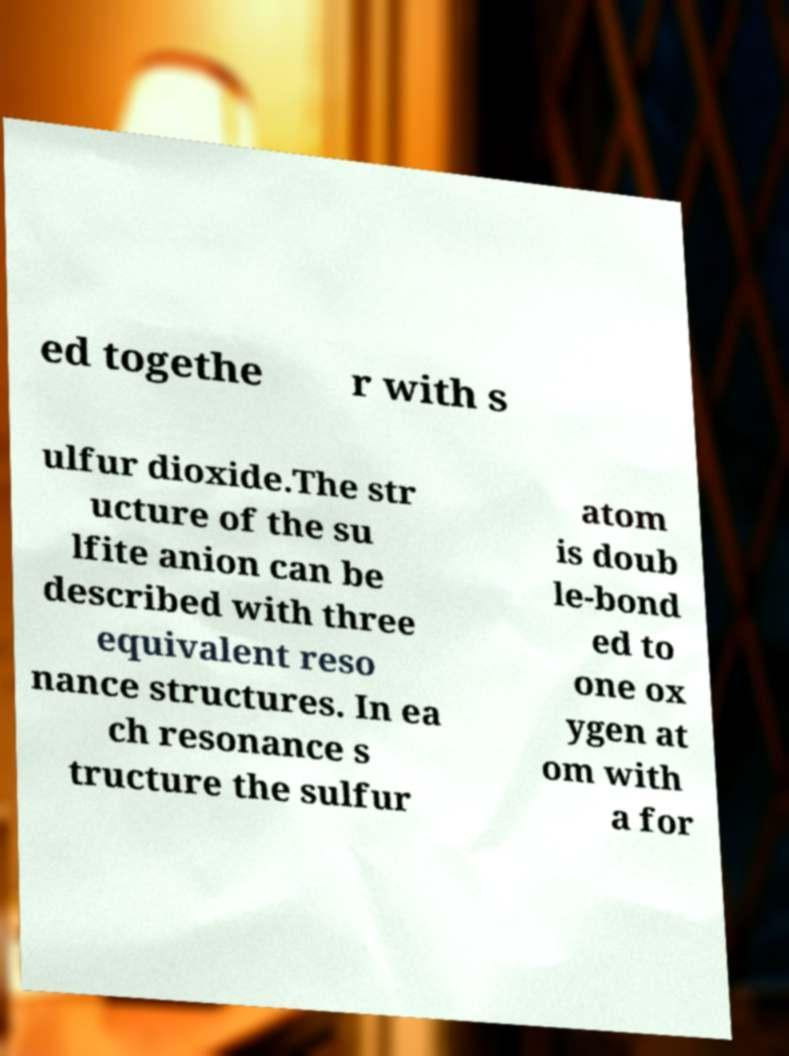I need the written content from this picture converted into text. Can you do that? ed togethe r with s ulfur dioxide.The str ucture of the su lfite anion can be described with three equivalent reso nance structures. In ea ch resonance s tructure the sulfur atom is doub le-bond ed to one ox ygen at om with a for 